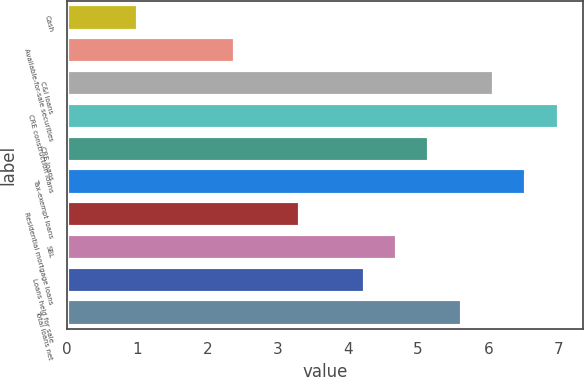Convert chart. <chart><loc_0><loc_0><loc_500><loc_500><bar_chart><fcel>Cash<fcel>Available-for-sale securities<fcel>C&I loans<fcel>CRE construction loans<fcel>CRE loans<fcel>Tax-exempt loans<fcel>Residential mortgage loans<fcel>SBL<fcel>Loans held for sale<fcel>Total loans net<nl><fcel>1.02<fcel>2.4<fcel>6.08<fcel>7<fcel>5.16<fcel>6.54<fcel>3.32<fcel>4.7<fcel>4.24<fcel>5.62<nl></chart> 